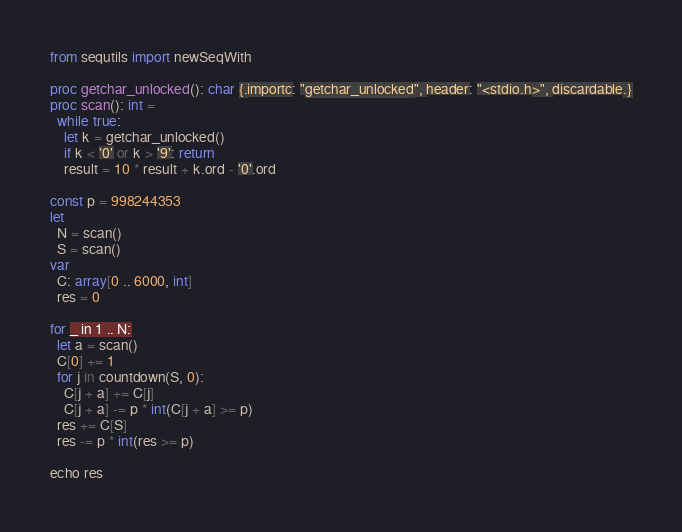Convert code to text. <code><loc_0><loc_0><loc_500><loc_500><_Nim_>from sequtils import newSeqWith

proc getchar_unlocked(): char {.importc: "getchar_unlocked", header: "<stdio.h>", discardable.}
proc scan(): int =
  while true:
    let k = getchar_unlocked()
    if k < '0' or k > '9': return
    result = 10 * result + k.ord - '0'.ord

const p = 998244353
let
  N = scan()
  S = scan()
var
  C: array[0 .. 6000, int]
  res = 0

for _ in 1 .. N:
  let a = scan()
  C[0] += 1
  for j in countdown(S, 0):
    C[j + a] += C[j]
    C[j + a] -= p * int(C[j + a] >= p)
  res += C[S]
  res -= p * int(res >= p)

echo res</code> 